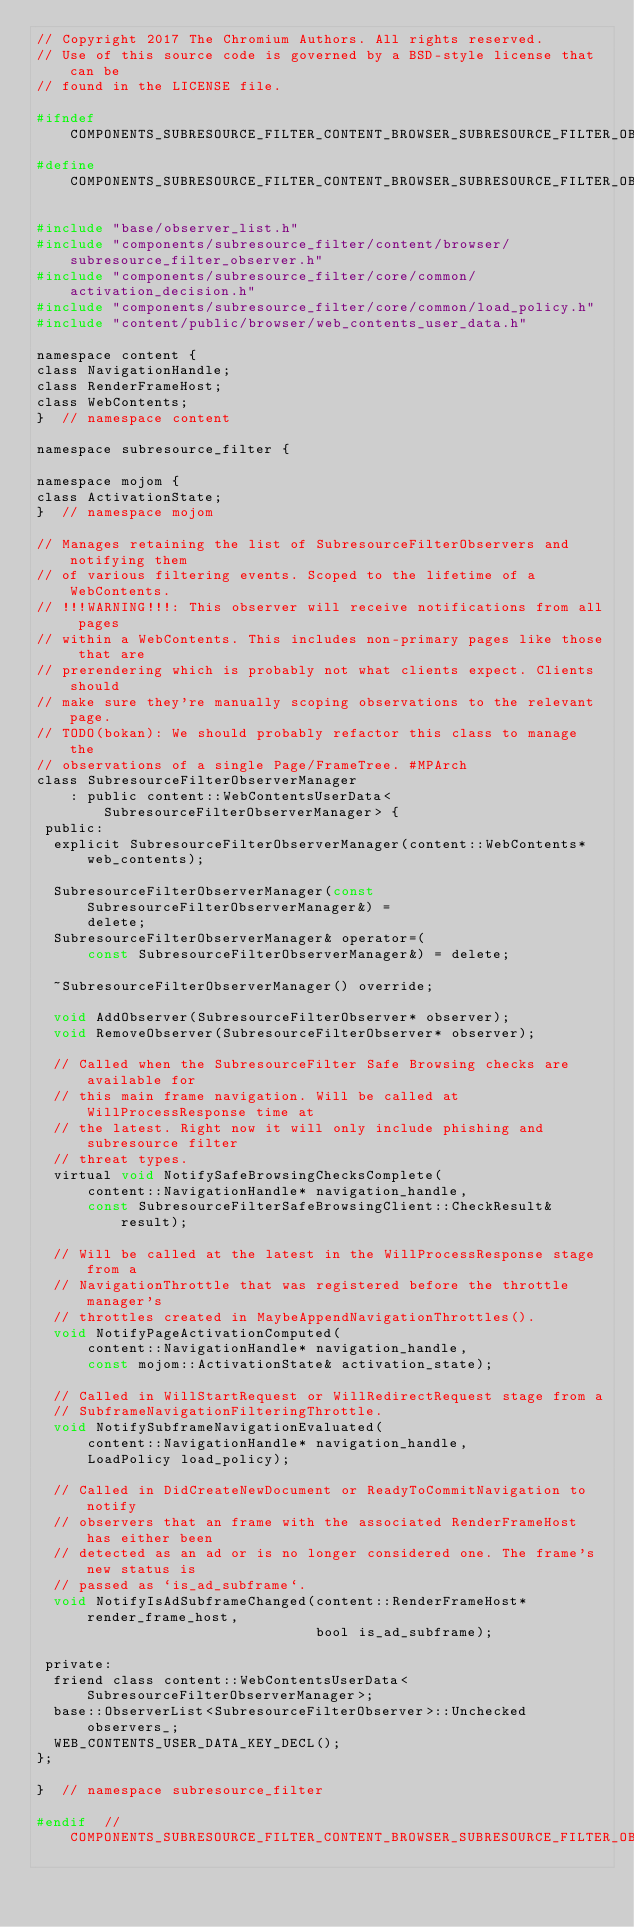Convert code to text. <code><loc_0><loc_0><loc_500><loc_500><_C_>// Copyright 2017 The Chromium Authors. All rights reserved.
// Use of this source code is governed by a BSD-style license that can be
// found in the LICENSE file.

#ifndef COMPONENTS_SUBRESOURCE_FILTER_CONTENT_BROWSER_SUBRESOURCE_FILTER_OBSERVER_MANAGER_H_
#define COMPONENTS_SUBRESOURCE_FILTER_CONTENT_BROWSER_SUBRESOURCE_FILTER_OBSERVER_MANAGER_H_

#include "base/observer_list.h"
#include "components/subresource_filter/content/browser/subresource_filter_observer.h"
#include "components/subresource_filter/core/common/activation_decision.h"
#include "components/subresource_filter/core/common/load_policy.h"
#include "content/public/browser/web_contents_user_data.h"

namespace content {
class NavigationHandle;
class RenderFrameHost;
class WebContents;
}  // namespace content

namespace subresource_filter {

namespace mojom {
class ActivationState;
}  // namespace mojom

// Manages retaining the list of SubresourceFilterObservers and notifying them
// of various filtering events. Scoped to the lifetime of a WebContents.
// !!!WARNING!!!: This observer will receive notifications from all pages
// within a WebContents. This includes non-primary pages like those that are
// prerendering which is probably not what clients expect. Clients should
// make sure they're manually scoping observations to the relevant page.
// TODO(bokan): We should probably refactor this class to manage the
// observations of a single Page/FrameTree. #MPArch
class SubresourceFilterObserverManager
    : public content::WebContentsUserData<SubresourceFilterObserverManager> {
 public:
  explicit SubresourceFilterObserverManager(content::WebContents* web_contents);

  SubresourceFilterObserverManager(const SubresourceFilterObserverManager&) =
      delete;
  SubresourceFilterObserverManager& operator=(
      const SubresourceFilterObserverManager&) = delete;

  ~SubresourceFilterObserverManager() override;

  void AddObserver(SubresourceFilterObserver* observer);
  void RemoveObserver(SubresourceFilterObserver* observer);

  // Called when the SubresourceFilter Safe Browsing checks are available for
  // this main frame navigation. Will be called at WillProcessResponse time at
  // the latest. Right now it will only include phishing and subresource filter
  // threat types.
  virtual void NotifySafeBrowsingChecksComplete(
      content::NavigationHandle* navigation_handle,
      const SubresourceFilterSafeBrowsingClient::CheckResult& result);

  // Will be called at the latest in the WillProcessResponse stage from a
  // NavigationThrottle that was registered before the throttle manager's
  // throttles created in MaybeAppendNavigationThrottles().
  void NotifyPageActivationComputed(
      content::NavigationHandle* navigation_handle,
      const mojom::ActivationState& activation_state);

  // Called in WillStartRequest or WillRedirectRequest stage from a
  // SubframeNavigationFilteringThrottle.
  void NotifySubframeNavigationEvaluated(
      content::NavigationHandle* navigation_handle,
      LoadPolicy load_policy);

  // Called in DidCreateNewDocument or ReadyToCommitNavigation to notify
  // observers that an frame with the associated RenderFrameHost has either been
  // detected as an ad or is no longer considered one. The frame's new status is
  // passed as `is_ad_subframe`.
  void NotifyIsAdSubframeChanged(content::RenderFrameHost* render_frame_host,
                                 bool is_ad_subframe);

 private:
  friend class content::WebContentsUserData<SubresourceFilterObserverManager>;
  base::ObserverList<SubresourceFilterObserver>::Unchecked observers_;
  WEB_CONTENTS_USER_DATA_KEY_DECL();
};

}  // namespace subresource_filter

#endif  // COMPONENTS_SUBRESOURCE_FILTER_CONTENT_BROWSER_SUBRESOURCE_FILTER_OBSERVER_MANAGER_H_
</code> 